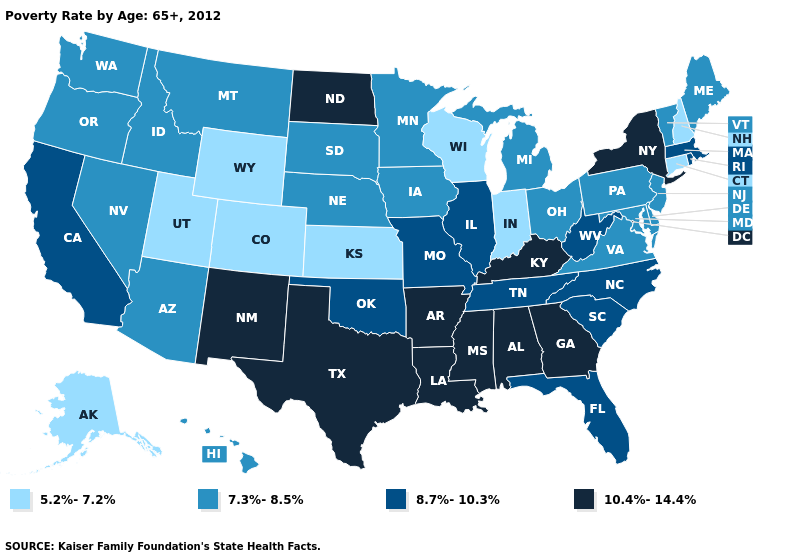Does Oregon have a higher value than Florida?
Write a very short answer. No. Is the legend a continuous bar?
Concise answer only. No. What is the value of New Mexico?
Short answer required. 10.4%-14.4%. What is the value of New Jersey?
Keep it brief. 7.3%-8.5%. What is the value of West Virginia?
Write a very short answer. 8.7%-10.3%. Does Oklahoma have the highest value in the USA?
Write a very short answer. No. What is the value of Mississippi?
Answer briefly. 10.4%-14.4%. Name the states that have a value in the range 7.3%-8.5%?
Quick response, please. Arizona, Delaware, Hawaii, Idaho, Iowa, Maine, Maryland, Michigan, Minnesota, Montana, Nebraska, Nevada, New Jersey, Ohio, Oregon, Pennsylvania, South Dakota, Vermont, Virginia, Washington. What is the highest value in the West ?
Keep it brief. 10.4%-14.4%. Which states have the highest value in the USA?
Write a very short answer. Alabama, Arkansas, Georgia, Kentucky, Louisiana, Mississippi, New Mexico, New York, North Dakota, Texas. Name the states that have a value in the range 5.2%-7.2%?
Quick response, please. Alaska, Colorado, Connecticut, Indiana, Kansas, New Hampshire, Utah, Wisconsin, Wyoming. Does California have a higher value than Alaska?
Give a very brief answer. Yes. What is the value of Texas?
Concise answer only. 10.4%-14.4%. Among the states that border New Jersey , does New York have the highest value?
Quick response, please. Yes. Does Texas have a higher value than North Carolina?
Quick response, please. Yes. 